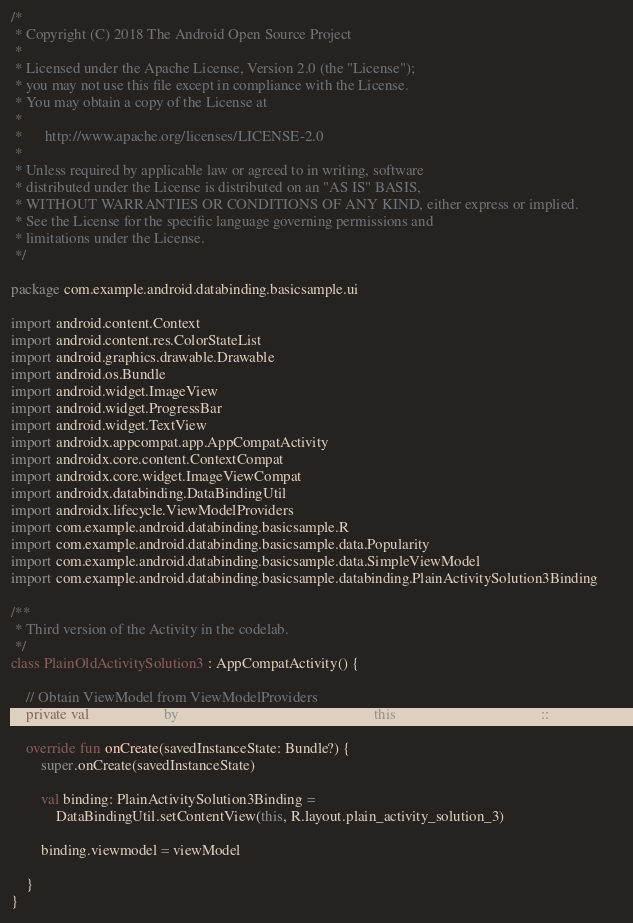Convert code to text. <code><loc_0><loc_0><loc_500><loc_500><_Kotlin_>/*
 * Copyright (C) 2018 The Android Open Source Project
 *
 * Licensed under the Apache License, Version 2.0 (the "License");
 * you may not use this file except in compliance with the License.
 * You may obtain a copy of the License at
 *
 *      http://www.apache.org/licenses/LICENSE-2.0
 *
 * Unless required by applicable law or agreed to in writing, software
 * distributed under the License is distributed on an "AS IS" BASIS,
 * WITHOUT WARRANTIES OR CONDITIONS OF ANY KIND, either express or implied.
 * See the License for the specific language governing permissions and
 * limitations under the License.
 */

package com.example.android.databinding.basicsample.ui

import android.content.Context
import android.content.res.ColorStateList
import android.graphics.drawable.Drawable
import android.os.Bundle
import android.widget.ImageView
import android.widget.ProgressBar
import android.widget.TextView
import androidx.appcompat.app.AppCompatActivity
import androidx.core.content.ContextCompat
import androidx.core.widget.ImageViewCompat
import androidx.databinding.DataBindingUtil
import androidx.lifecycle.ViewModelProviders
import com.example.android.databinding.basicsample.R
import com.example.android.databinding.basicsample.data.Popularity
import com.example.android.databinding.basicsample.data.SimpleViewModel
import com.example.android.databinding.basicsample.databinding.PlainActivitySolution3Binding

/**
 * Third version of the Activity in the codelab.
 */
class PlainOldActivitySolution3 : AppCompatActivity() {

    // Obtain ViewModel from ViewModelProviders
    private val viewModel by lazy { ViewModelProviders.of(this).get(SimpleViewModel::class.java) }

    override fun onCreate(savedInstanceState: Bundle?) {
        super.onCreate(savedInstanceState)

        val binding: PlainActivitySolution3Binding =
            DataBindingUtil.setContentView(this, R.layout.plain_activity_solution_3)

        binding.viewmodel = viewModel

    }
}
</code> 